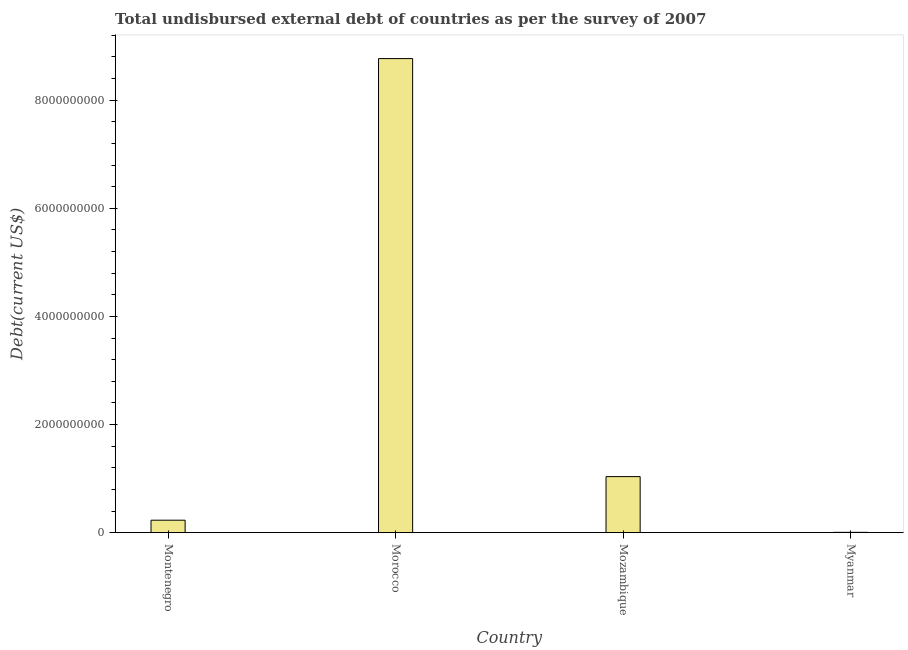What is the title of the graph?
Make the answer very short. Total undisbursed external debt of countries as per the survey of 2007. What is the label or title of the Y-axis?
Provide a short and direct response. Debt(current US$). What is the total debt in Montenegro?
Offer a very short reply. 2.31e+08. Across all countries, what is the maximum total debt?
Keep it short and to the point. 8.77e+09. Across all countries, what is the minimum total debt?
Offer a very short reply. 6.84e+06. In which country was the total debt maximum?
Your response must be concise. Morocco. In which country was the total debt minimum?
Provide a succinct answer. Myanmar. What is the sum of the total debt?
Your answer should be compact. 1.00e+1. What is the difference between the total debt in Morocco and Mozambique?
Your answer should be very brief. 7.73e+09. What is the average total debt per country?
Make the answer very short. 2.51e+09. What is the median total debt?
Keep it short and to the point. 6.35e+08. What is the ratio of the total debt in Montenegro to that in Myanmar?
Your response must be concise. 33.83. What is the difference between the highest and the second highest total debt?
Keep it short and to the point. 7.73e+09. Is the sum of the total debt in Morocco and Myanmar greater than the maximum total debt across all countries?
Provide a short and direct response. Yes. What is the difference between the highest and the lowest total debt?
Your response must be concise. 8.76e+09. In how many countries, is the total debt greater than the average total debt taken over all countries?
Give a very brief answer. 1. How many bars are there?
Ensure brevity in your answer.  4. What is the difference between two consecutive major ticks on the Y-axis?
Keep it short and to the point. 2.00e+09. What is the Debt(current US$) in Montenegro?
Your answer should be very brief. 2.31e+08. What is the Debt(current US$) in Morocco?
Keep it short and to the point. 8.77e+09. What is the Debt(current US$) of Mozambique?
Your answer should be very brief. 1.04e+09. What is the Debt(current US$) of Myanmar?
Make the answer very short. 6.84e+06. What is the difference between the Debt(current US$) in Montenegro and Morocco?
Offer a terse response. -8.54e+09. What is the difference between the Debt(current US$) in Montenegro and Mozambique?
Keep it short and to the point. -8.06e+08. What is the difference between the Debt(current US$) in Montenegro and Myanmar?
Your answer should be compact. 2.25e+08. What is the difference between the Debt(current US$) in Morocco and Mozambique?
Your answer should be very brief. 7.73e+09. What is the difference between the Debt(current US$) in Morocco and Myanmar?
Offer a terse response. 8.76e+09. What is the difference between the Debt(current US$) in Mozambique and Myanmar?
Keep it short and to the point. 1.03e+09. What is the ratio of the Debt(current US$) in Montenegro to that in Morocco?
Provide a succinct answer. 0.03. What is the ratio of the Debt(current US$) in Montenegro to that in Mozambique?
Your response must be concise. 0.22. What is the ratio of the Debt(current US$) in Montenegro to that in Myanmar?
Provide a succinct answer. 33.83. What is the ratio of the Debt(current US$) in Morocco to that in Mozambique?
Keep it short and to the point. 8.45. What is the ratio of the Debt(current US$) in Morocco to that in Myanmar?
Ensure brevity in your answer.  1281.83. What is the ratio of the Debt(current US$) in Mozambique to that in Myanmar?
Provide a succinct answer. 151.65. 